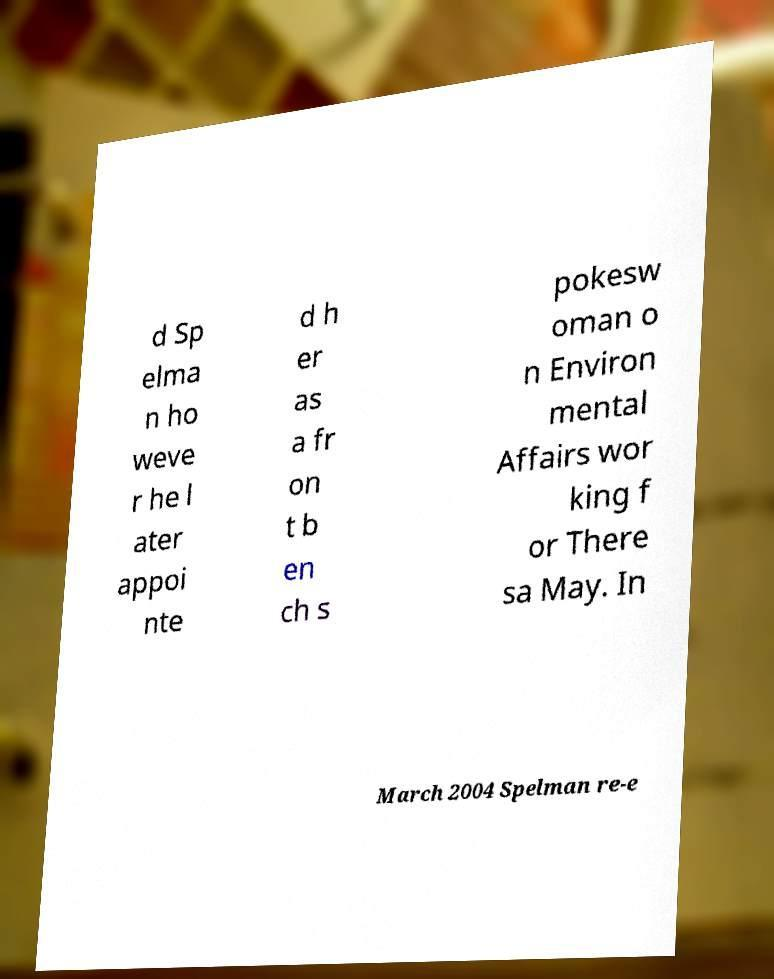I need the written content from this picture converted into text. Can you do that? d Sp elma n ho weve r he l ater appoi nte d h er as a fr on t b en ch s pokesw oman o n Environ mental Affairs wor king f or There sa May. In March 2004 Spelman re-e 